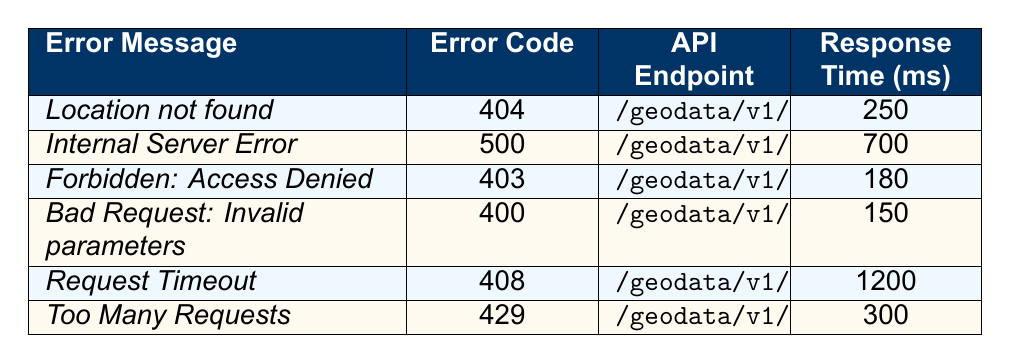What is the error message for user ID user_8391? In the table, locate the entry with user ID user_8391. The associated error message is "Location not found."
Answer: Location not found How many unique error codes are listed in the table? The unique error codes in the table are 404, 500, 403, 400, 408, and 429. There are 6 unique error codes.
Answer: 6 Which API endpoint had the longest response time? The entry with the longest response time is the API endpoint "/geodata/v1/autocomplete," which has a response time of 1200 ms.
Answer: /geodata/v1/autocomplete Is there an error related to "Too Many Requests"? Yes, there is an error with the message "Too Many Requests" which corresponds to error code 429.
Answer: Yes What is the average response time of all the API interactions listed in the table? The response times are: 250, 700, 180, 150, 1200, and 300. Summing these gives 2880 ms. There are 6 entries, so the average response time is 2880 ms / 6 = 480 ms.
Answer: 480 ms Which error code corresponds to "Request Timeout"? In the table, "Request Timeout" corresponds to error code 408.
Answer: 408 How many errors occurred on the same or a later date than September 20, 2023? The entries on or later than September 20, 2023, are from September 28 and September 30. There are 3 errors in total from September 20 onward.
Answer: 3 What is the error message for the API endpoint "/geodata/v1/history"? The API endpoint "/geodata/v1/history" has the error message "Forbidden: Access Denied."
Answer: Forbidden: Access Denied Which user experienced the "Internal Server Error" and what was their response time? The entry for the "Internal Server Error" shows that user ID user_7462 experienced this error, with a response time of 700 ms.
Answer: user_7462, 700 ms What is the difference in response time between the fastest and slowest errors? The fastest response time is 150 ms (Bad Request), and the slowest response time is 1200 ms (Request Timeout). The difference is 1200 ms - 150 ms = 1050 ms.
Answer: 1050 ms 